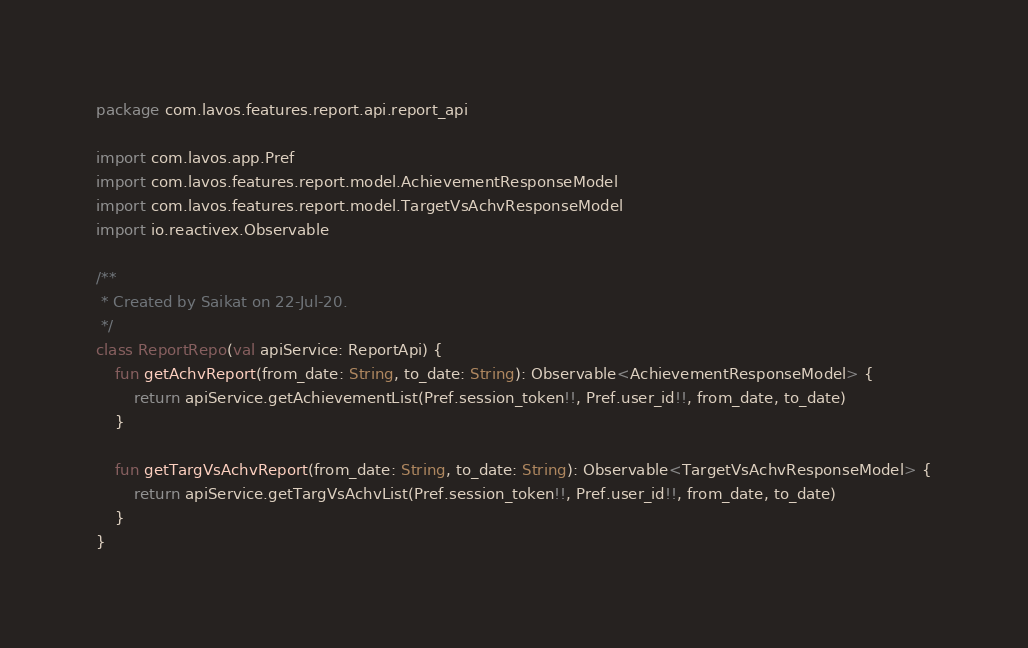Convert code to text. <code><loc_0><loc_0><loc_500><loc_500><_Kotlin_>package com.lavos.features.report.api.report_api

import com.lavos.app.Pref
import com.lavos.features.report.model.AchievementResponseModel
import com.lavos.features.report.model.TargetVsAchvResponseModel
import io.reactivex.Observable

/**
 * Created by Saikat on 22-Jul-20.
 */
class ReportRepo(val apiService: ReportApi) {
    fun getAchvReport(from_date: String, to_date: String): Observable<AchievementResponseModel> {
        return apiService.getAchievementList(Pref.session_token!!, Pref.user_id!!, from_date, to_date)
    }

    fun getTargVsAchvReport(from_date: String, to_date: String): Observable<TargetVsAchvResponseModel> {
        return apiService.getTargVsAchvList(Pref.session_token!!, Pref.user_id!!, from_date, to_date)
    }
}</code> 